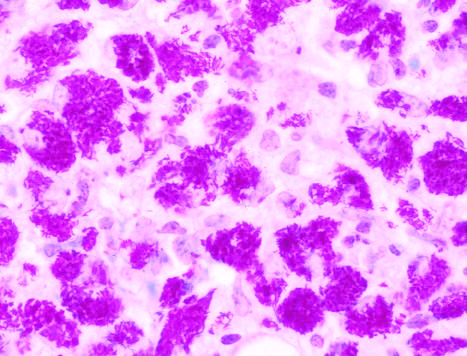what are sheets of macrophages packed with mycobacteria seen in?
Answer the question using a single word or phrase. A specimen from an immunosuppressed patient 